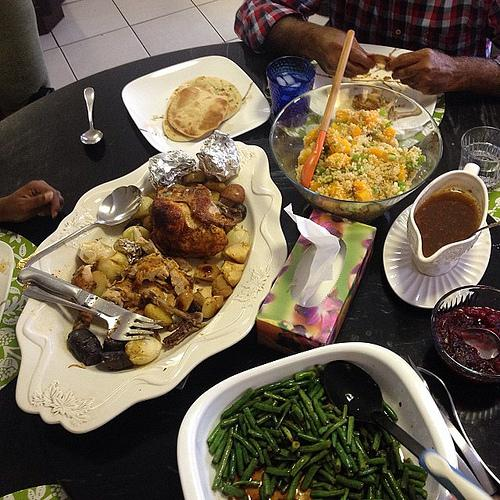Question: where was the picture taken?
Choices:
A. In a kitchen.
B. In a Diner.
C. In a mall.
D. In a living room.
Answer with the letter. Answer: A Question: who is eating?
Choices:
A. A child.
B. A man.
C. A family.
D. The guest of honor.
Answer with the letter. Answer: B Question: what is he holding?
Choices:
A. Bread.
B. A cat.
C. Clothing.
D. Money.
Answer with the letter. Answer: A 